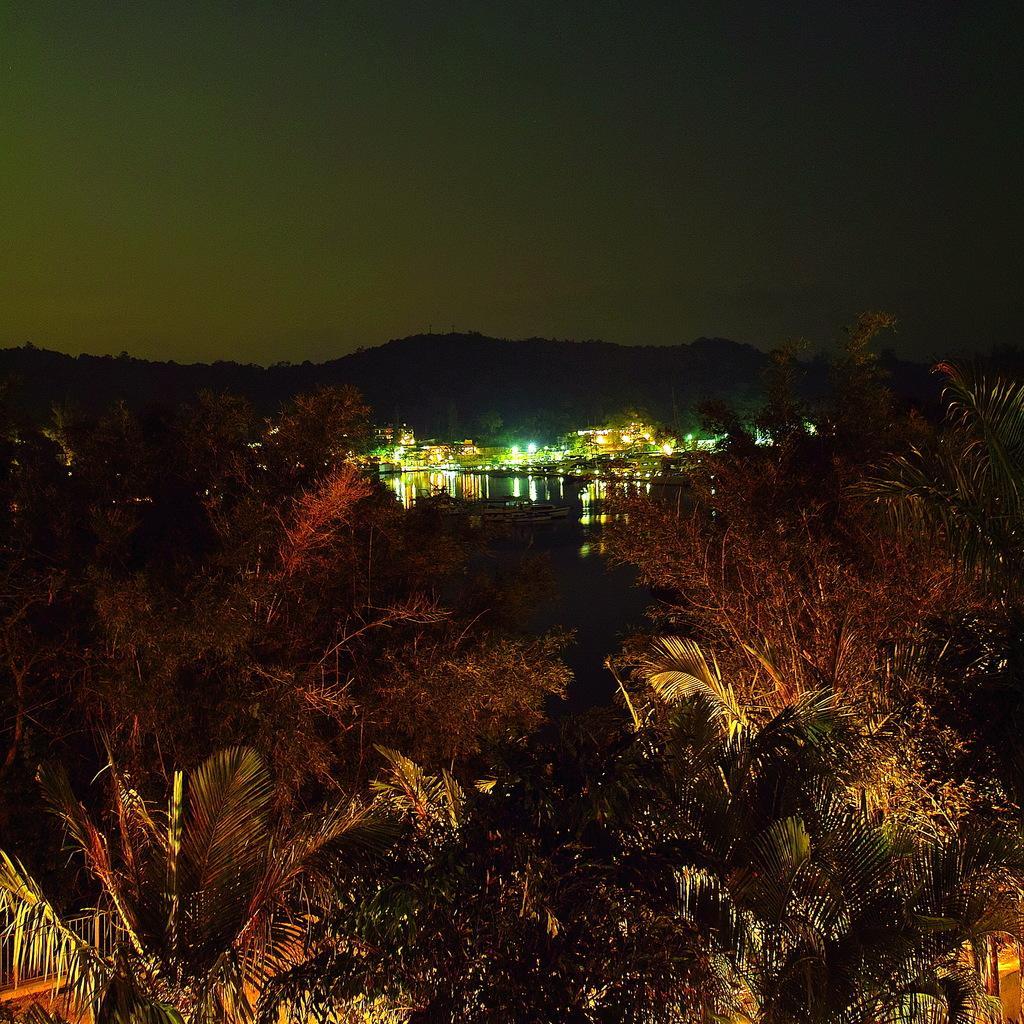How would you summarize this image in a sentence or two? In the image we can see trees, buildings, lights, mountain and a sky. 